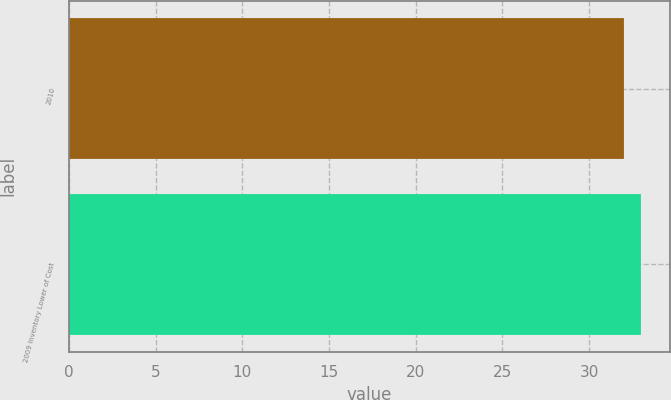<chart> <loc_0><loc_0><loc_500><loc_500><bar_chart><fcel>2010<fcel>2009 Inventory Lower of Cost<nl><fcel>32<fcel>33<nl></chart> 